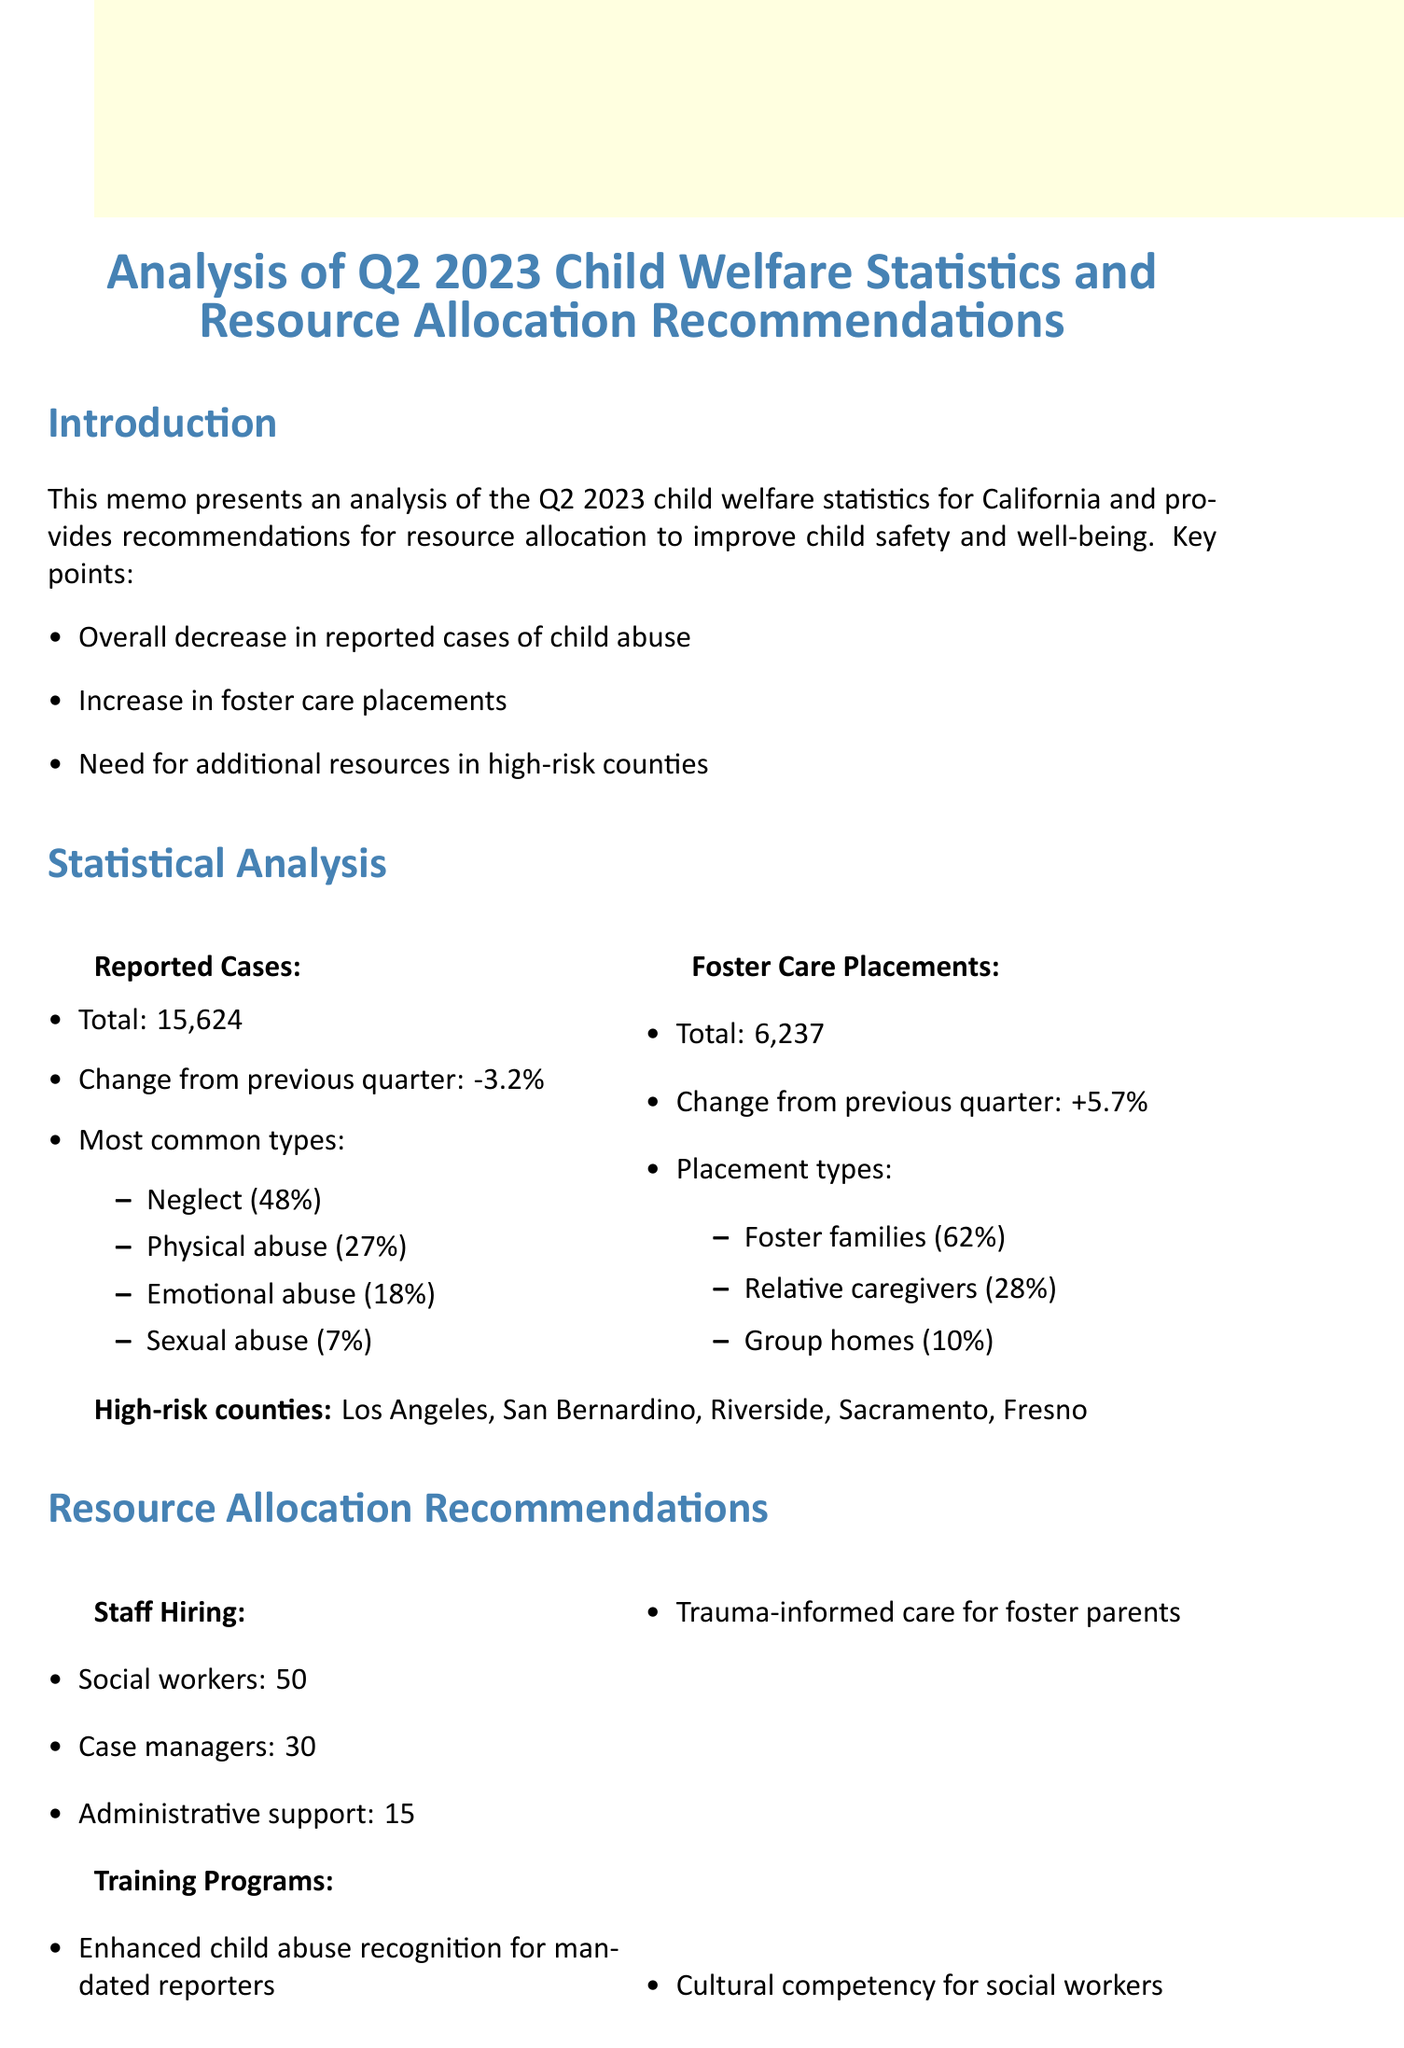What is the total number of reported cases of child abuse? The total number of reported cases of child abuse is stated in the document, which is 15,624.
Answer: 15,624 What percentage of reported child abuse cases was neglect? The document provides the most common types of child abuse, with neglect accounting for 48%.
Answer: 48% Which county has the highest number of high-risk cases? The document lists high-risk counties, with Los Angeles being the first mentioned, indicating its significance.
Answer: Los Angeles How many social workers are recommended for hiring? The memo recommends hiring an additional 50 social workers as part of the resource allocation plan.
Answer: 50 What is the total requested budget increase? The document states the total requested increase in the budget as $8.5 million.
Answer: $8.5 million What training program is suggested for foster parents? The document lists training programs, including Trauma-informed care for foster parents, which is a notable suggestion.
Answer: Trauma-informed care for foster parents What percentage of foster care placements are with foster families? The document specifies that 62% of foster care placements are with foster families.
Answer: 62% What is one potential funding source mentioned? The document mentions multiple potential funding sources, with the State Child Welfare Services budget being one specific example.
Answer: State Child Welfare Services budget What is the main goal of the proposed resource allocation? The conclusion highlights that the goal is to address increasing demand for foster care placements and enhance child safety outcomes.
Answer: Improve child safety outcomes 